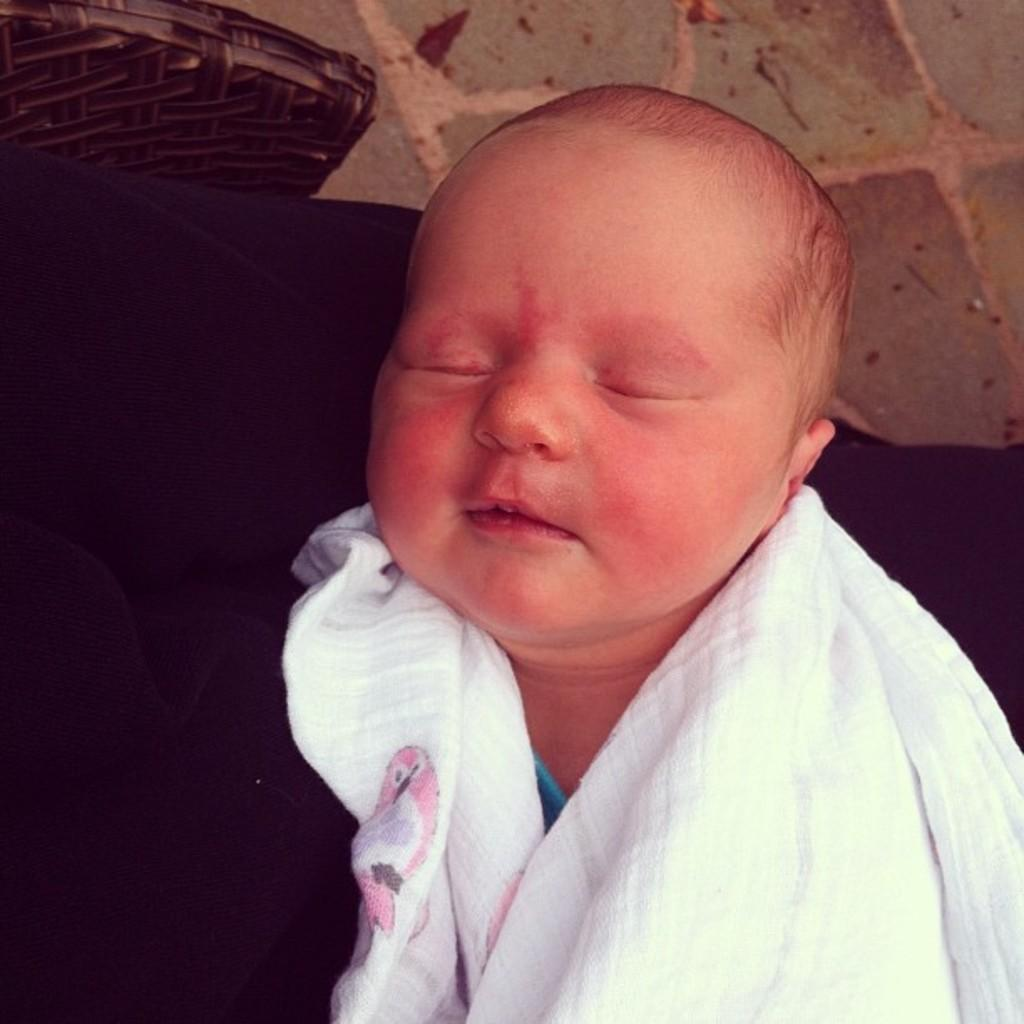What is the main subject of the image? There is a baby sleeping in the image. What else can be seen in the image besides the baby? There are clothes visible in the image. What part of the room is visible at the top of the image? The floor is visible at the top of the image. Can you describe the object on the floor? There is an unspecified object on the floor. What type of yam is being used as a pillow for the baby in the image? There is no yam present in the image; the baby is sleeping on a surface that is not specified. 